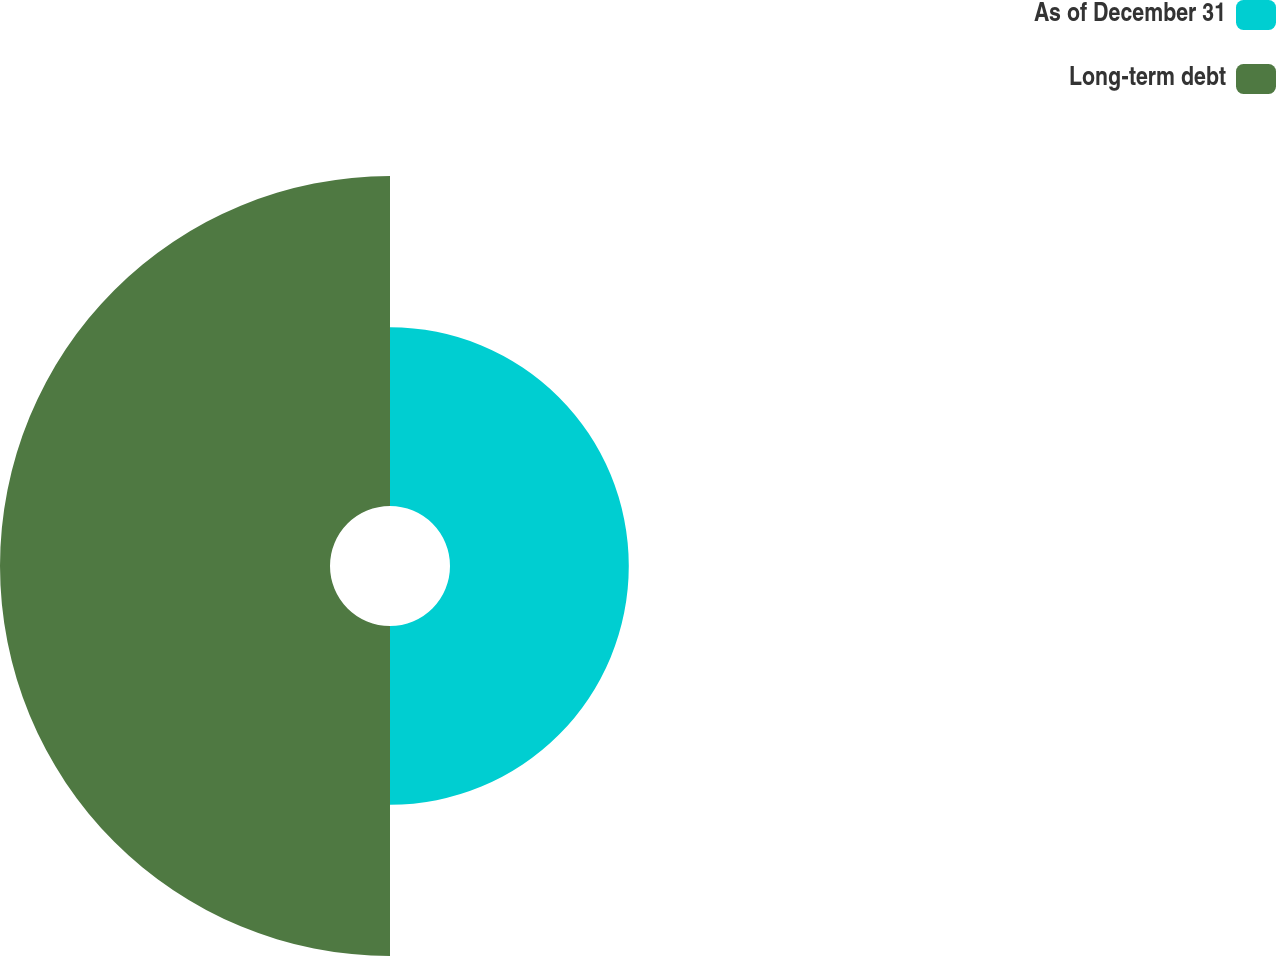<chart> <loc_0><loc_0><loc_500><loc_500><pie_chart><fcel>As of December 31<fcel>Long-term debt<nl><fcel>35.14%<fcel>64.86%<nl></chart> 